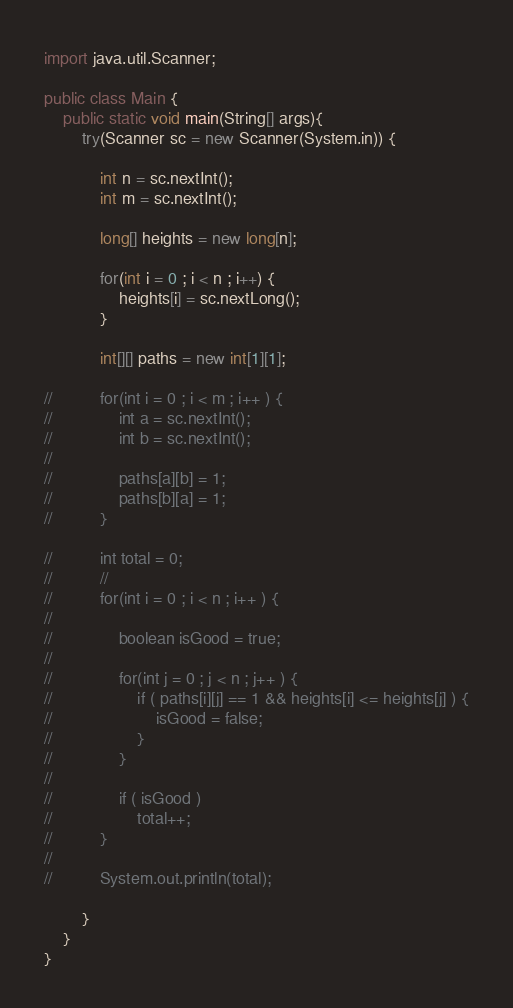Convert code to text. <code><loc_0><loc_0><loc_500><loc_500><_Java_>import java.util.Scanner;

public class Main {
	public static void main(String[] args){
		try(Scanner sc = new Scanner(System.in)) {

			int n = sc.nextInt();
			int m = sc.nextInt();

			long[] heights = new long[n];

			for(int i = 0 ; i < n ; i++) {
				heights[i] = sc.nextLong();
			}

			int[][] paths = new int[1][1];

//			for(int i = 0 ; i < m ; i++ ) {
//				int a = sc.nextInt();
//				int b = sc.nextInt();
//
//				paths[a][b] = 1;
//				paths[b][a] = 1;
//			}

//			int total = 0;
//			//
//			for(int i = 0 ; i < n ; i++ ) {
//
//				boolean isGood = true;
//
//				for(int j = 0 ; j < n ; j++ ) {
//					if ( paths[i][j] == 1 && heights[i] <= heights[j] ) {
//						isGood = false;
//					}					
//				}
//
//				if ( isGood )
//					total++;
//			}
//
//			System.out.println(total);

		}
	}
}</code> 